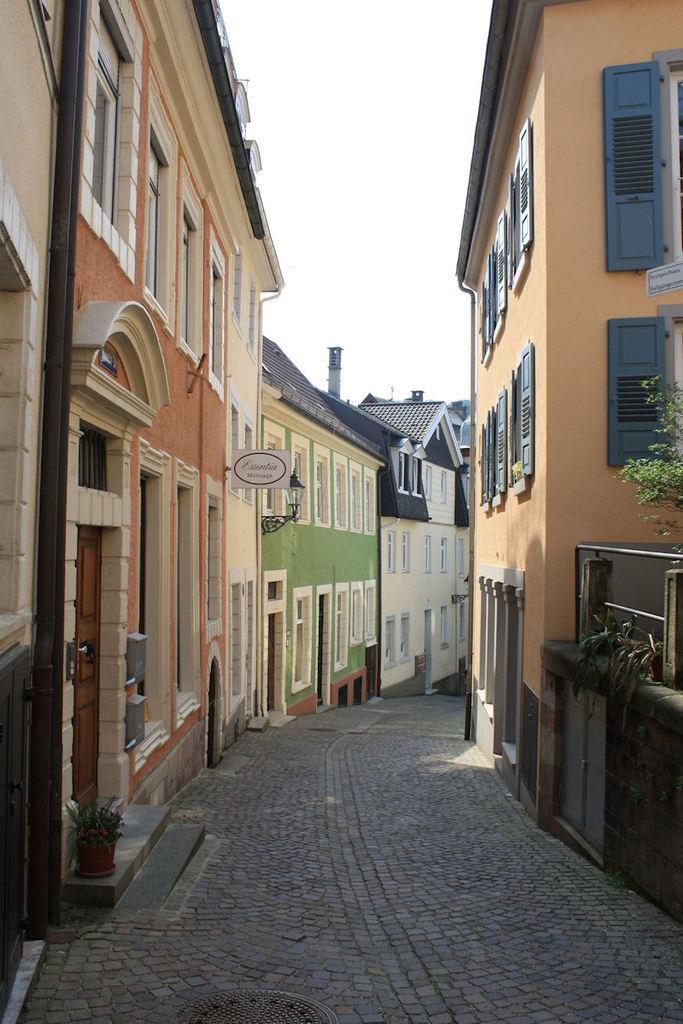Describe this image in one or two sentences. In this image we can see the houses with the windows and road, plants in a pots, wall, some written text on the board, we can see the sky. 